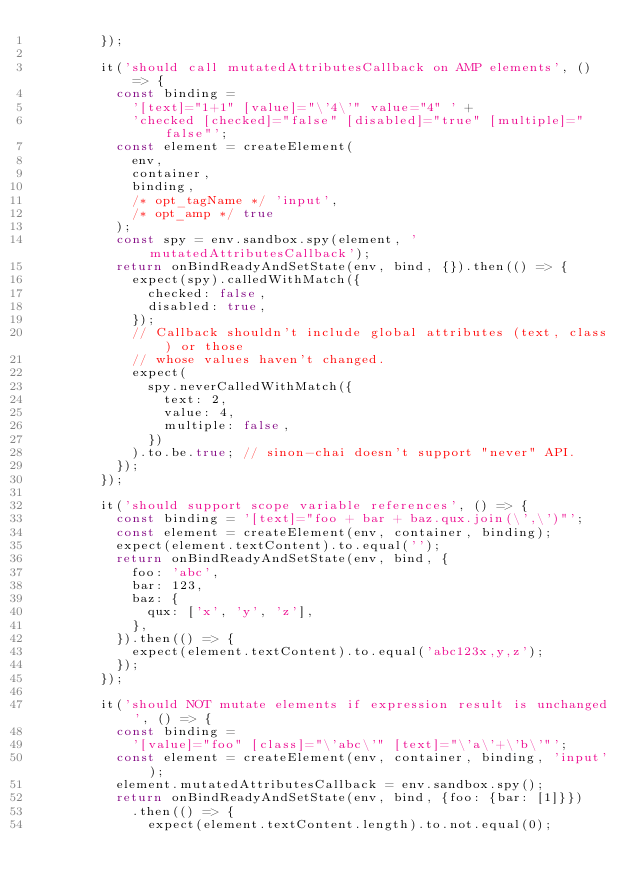<code> <loc_0><loc_0><loc_500><loc_500><_JavaScript_>        });

        it('should call mutatedAttributesCallback on AMP elements', () => {
          const binding =
            '[text]="1+1" [value]="\'4\'" value="4" ' +
            'checked [checked]="false" [disabled]="true" [multiple]="false"';
          const element = createElement(
            env,
            container,
            binding,
            /* opt_tagName */ 'input',
            /* opt_amp */ true
          );
          const spy = env.sandbox.spy(element, 'mutatedAttributesCallback');
          return onBindReadyAndSetState(env, bind, {}).then(() => {
            expect(spy).calledWithMatch({
              checked: false,
              disabled: true,
            });
            // Callback shouldn't include global attributes (text, class) or those
            // whose values haven't changed.
            expect(
              spy.neverCalledWithMatch({
                text: 2,
                value: 4,
                multiple: false,
              })
            ).to.be.true; // sinon-chai doesn't support "never" API.
          });
        });

        it('should support scope variable references', () => {
          const binding = '[text]="foo + bar + baz.qux.join(\',\')"';
          const element = createElement(env, container, binding);
          expect(element.textContent).to.equal('');
          return onBindReadyAndSetState(env, bind, {
            foo: 'abc',
            bar: 123,
            baz: {
              qux: ['x', 'y', 'z'],
            },
          }).then(() => {
            expect(element.textContent).to.equal('abc123x,y,z');
          });
        });

        it('should NOT mutate elements if expression result is unchanged', () => {
          const binding =
            '[value]="foo" [class]="\'abc\'" [text]="\'a\'+\'b\'"';
          const element = createElement(env, container, binding, 'input');
          element.mutatedAttributesCallback = env.sandbox.spy();
          return onBindReadyAndSetState(env, bind, {foo: {bar: [1]}})
            .then(() => {
              expect(element.textContent.length).to.not.equal(0);</code> 